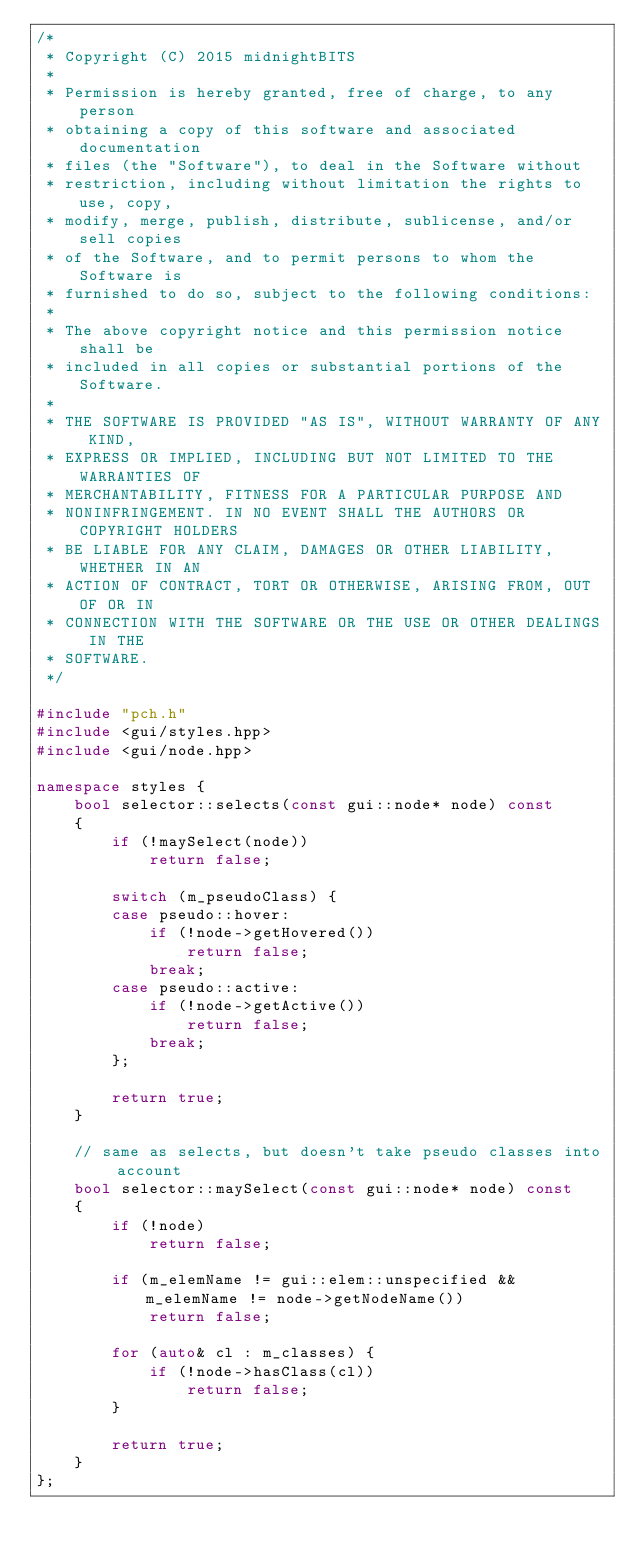Convert code to text. <code><loc_0><loc_0><loc_500><loc_500><_C++_>/*
 * Copyright (C) 2015 midnightBITS
 *
 * Permission is hereby granted, free of charge, to any person
 * obtaining a copy of this software and associated documentation
 * files (the "Software"), to deal in the Software without
 * restriction, including without limitation the rights to use, copy,
 * modify, merge, publish, distribute, sublicense, and/or sell copies
 * of the Software, and to permit persons to whom the Software is
 * furnished to do so, subject to the following conditions:
 *
 * The above copyright notice and this permission notice shall be
 * included in all copies or substantial portions of the Software.
 *
 * THE SOFTWARE IS PROVIDED "AS IS", WITHOUT WARRANTY OF ANY KIND,
 * EXPRESS OR IMPLIED, INCLUDING BUT NOT LIMITED TO THE WARRANTIES OF
 * MERCHANTABILITY, FITNESS FOR A PARTICULAR PURPOSE AND
 * NONINFRINGEMENT. IN NO EVENT SHALL THE AUTHORS OR COPYRIGHT HOLDERS
 * BE LIABLE FOR ANY CLAIM, DAMAGES OR OTHER LIABILITY, WHETHER IN AN
 * ACTION OF CONTRACT, TORT OR OTHERWISE, ARISING FROM, OUT OF OR IN
 * CONNECTION WITH THE SOFTWARE OR THE USE OR OTHER DEALINGS IN THE
 * SOFTWARE.
 */

#include "pch.h"
#include <gui/styles.hpp>
#include <gui/node.hpp>

namespace styles {
	bool selector::selects(const gui::node* node) const
	{
		if (!maySelect(node))
			return false;

		switch (m_pseudoClass) {
		case pseudo::hover:
			if (!node->getHovered())
				return false;
			break;
		case pseudo::active:
			if (!node->getActive())
				return false;
			break;
		};

		return true;
	}

	// same as selects, but doesn't take pseudo classes into account
	bool selector::maySelect(const gui::node* node) const
	{
		if (!node)
			return false;

		if (m_elemName != gui::elem::unspecified && m_elemName != node->getNodeName())
			return false;

		for (auto& cl : m_classes) {
			if (!node->hasClass(cl))
				return false;
		}

		return true;
	}
};</code> 